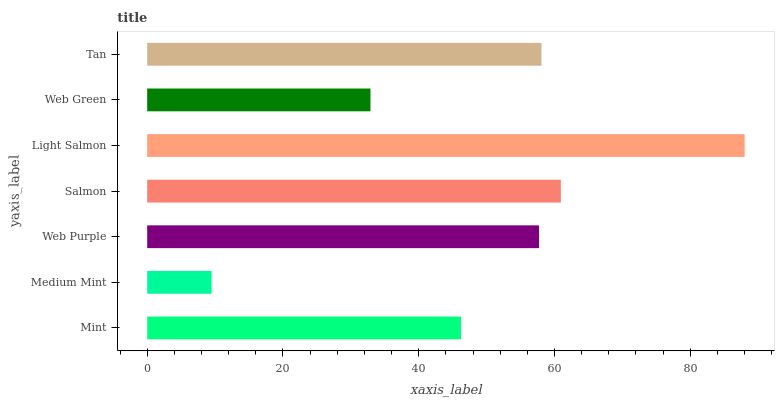Is Medium Mint the minimum?
Answer yes or no. Yes. Is Light Salmon the maximum?
Answer yes or no. Yes. Is Web Purple the minimum?
Answer yes or no. No. Is Web Purple the maximum?
Answer yes or no. No. Is Web Purple greater than Medium Mint?
Answer yes or no. Yes. Is Medium Mint less than Web Purple?
Answer yes or no. Yes. Is Medium Mint greater than Web Purple?
Answer yes or no. No. Is Web Purple less than Medium Mint?
Answer yes or no. No. Is Web Purple the high median?
Answer yes or no. Yes. Is Web Purple the low median?
Answer yes or no. Yes. Is Mint the high median?
Answer yes or no. No. Is Salmon the low median?
Answer yes or no. No. 